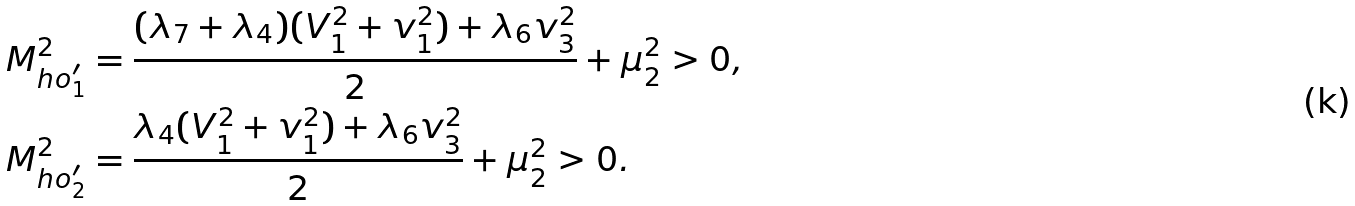Convert formula to latex. <formula><loc_0><loc_0><loc_500><loc_500>M _ { h o ^ { \prime } _ { 1 } } ^ { 2 } & = \frac { ( \lambda _ { 7 } + \lambda _ { 4 } ) ( V _ { 1 } ^ { 2 } + v _ { 1 } ^ { 2 } ) + \lambda _ { 6 } v _ { 3 } ^ { 2 } } { 2 } + \mu _ { 2 } ^ { 2 } > 0 , \\ M _ { h o ^ { \prime } _ { 2 } } ^ { 2 } & = \frac { \lambda _ { 4 } ( V _ { 1 } ^ { 2 } + v _ { 1 } ^ { 2 } ) + \lambda _ { 6 } v _ { 3 } ^ { 2 } } { 2 } + \mu _ { 2 } ^ { 2 } > 0 .</formula> 